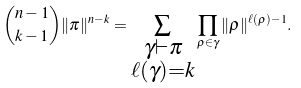Convert formula to latex. <formula><loc_0><loc_0><loc_500><loc_500>\binom { n - 1 } { k - 1 } \| \pi \| ^ { n - k } = \sum _ { \substack { \gamma \vdash \pi \\ \ell ( \gamma ) = k } } \prod _ { \rho \in \gamma } \| \rho \| ^ { \ell ( \rho ) - 1 } .</formula> 